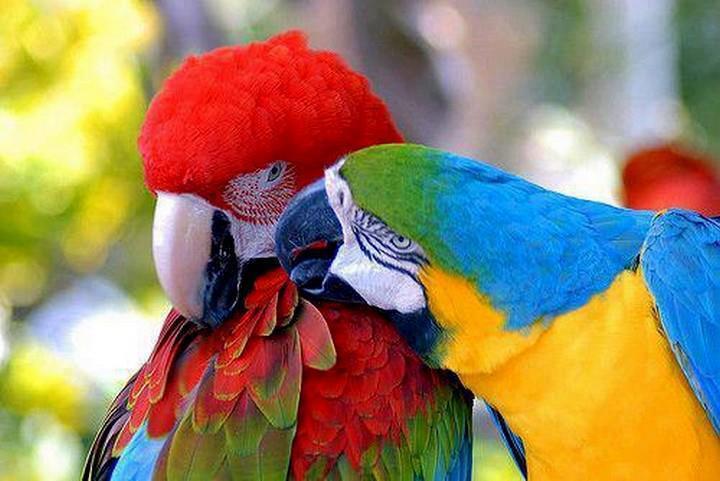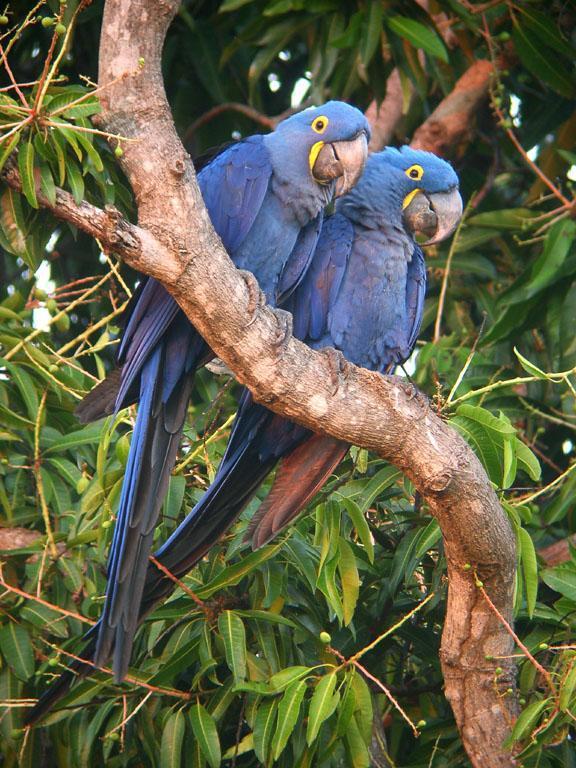The first image is the image on the left, the second image is the image on the right. For the images displayed, is the sentence "One image shows two solid-blue parrots perched on a branch, and the other image shows one red-headed bird next to a blue-and-yellow bird." factually correct? Answer yes or no. Yes. The first image is the image on the left, the second image is the image on the right. Assess this claim about the two images: "There are two blue birds perching on the same branch in one of the images.". Correct or not? Answer yes or no. Yes. 